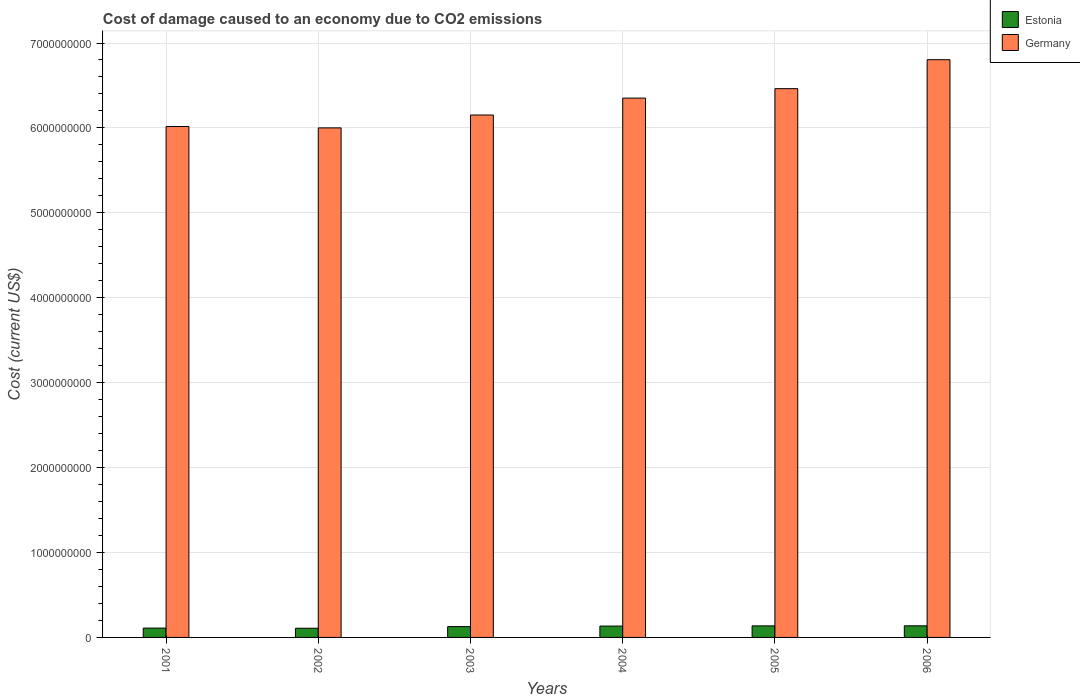How many different coloured bars are there?
Your answer should be very brief. 2. How many groups of bars are there?
Make the answer very short. 6. Are the number of bars per tick equal to the number of legend labels?
Your answer should be compact. Yes. What is the label of the 2nd group of bars from the left?
Your response must be concise. 2002. In how many cases, is the number of bars for a given year not equal to the number of legend labels?
Your answer should be very brief. 0. What is the cost of damage caused due to CO2 emissisons in Germany in 2005?
Provide a succinct answer. 6.46e+09. Across all years, what is the maximum cost of damage caused due to CO2 emissisons in Estonia?
Ensure brevity in your answer.  1.37e+08. Across all years, what is the minimum cost of damage caused due to CO2 emissisons in Estonia?
Provide a short and direct response. 1.08e+08. In which year was the cost of damage caused due to CO2 emissisons in Estonia minimum?
Your answer should be compact. 2002. What is the total cost of damage caused due to CO2 emissisons in Estonia in the graph?
Provide a short and direct response. 7.52e+08. What is the difference between the cost of damage caused due to CO2 emissisons in Estonia in 2001 and that in 2003?
Ensure brevity in your answer.  -1.75e+07. What is the difference between the cost of damage caused due to CO2 emissisons in Estonia in 2005 and the cost of damage caused due to CO2 emissisons in Germany in 2001?
Offer a very short reply. -5.88e+09. What is the average cost of damage caused due to CO2 emissisons in Germany per year?
Ensure brevity in your answer.  6.30e+09. In the year 2006, what is the difference between the cost of damage caused due to CO2 emissisons in Estonia and cost of damage caused due to CO2 emissisons in Germany?
Keep it short and to the point. -6.67e+09. In how many years, is the cost of damage caused due to CO2 emissisons in Germany greater than 5400000000 US$?
Your answer should be very brief. 6. What is the ratio of the cost of damage caused due to CO2 emissisons in Estonia in 2001 to that in 2006?
Give a very brief answer. 0.8. What is the difference between the highest and the second highest cost of damage caused due to CO2 emissisons in Germany?
Provide a succinct answer. 3.41e+08. What is the difference between the highest and the lowest cost of damage caused due to CO2 emissisons in Germany?
Your response must be concise. 8.03e+08. What does the 2nd bar from the left in 2006 represents?
Provide a succinct answer. Germany. What does the 1st bar from the right in 2005 represents?
Offer a very short reply. Germany. Are all the bars in the graph horizontal?
Your response must be concise. No. Are the values on the major ticks of Y-axis written in scientific E-notation?
Keep it short and to the point. No. Does the graph contain any zero values?
Keep it short and to the point. No. Does the graph contain grids?
Offer a very short reply. Yes. Where does the legend appear in the graph?
Your response must be concise. Top right. What is the title of the graph?
Ensure brevity in your answer.  Cost of damage caused to an economy due to CO2 emissions. Does "Guyana" appear as one of the legend labels in the graph?
Your answer should be very brief. No. What is the label or title of the X-axis?
Give a very brief answer. Years. What is the label or title of the Y-axis?
Provide a short and direct response. Cost (current US$). What is the Cost (current US$) in Estonia in 2001?
Provide a succinct answer. 1.10e+08. What is the Cost (current US$) of Germany in 2001?
Keep it short and to the point. 6.02e+09. What is the Cost (current US$) of Estonia in 2002?
Keep it short and to the point. 1.08e+08. What is the Cost (current US$) in Germany in 2002?
Give a very brief answer. 6.00e+09. What is the Cost (current US$) in Estonia in 2003?
Offer a terse response. 1.27e+08. What is the Cost (current US$) in Germany in 2003?
Make the answer very short. 6.15e+09. What is the Cost (current US$) in Estonia in 2004?
Make the answer very short. 1.34e+08. What is the Cost (current US$) of Germany in 2004?
Provide a short and direct response. 6.35e+09. What is the Cost (current US$) of Estonia in 2005?
Provide a succinct answer. 1.36e+08. What is the Cost (current US$) of Germany in 2005?
Keep it short and to the point. 6.46e+09. What is the Cost (current US$) of Estonia in 2006?
Keep it short and to the point. 1.37e+08. What is the Cost (current US$) in Germany in 2006?
Your answer should be very brief. 6.80e+09. Across all years, what is the maximum Cost (current US$) in Estonia?
Provide a short and direct response. 1.37e+08. Across all years, what is the maximum Cost (current US$) of Germany?
Keep it short and to the point. 6.80e+09. Across all years, what is the minimum Cost (current US$) in Estonia?
Keep it short and to the point. 1.08e+08. Across all years, what is the minimum Cost (current US$) of Germany?
Ensure brevity in your answer.  6.00e+09. What is the total Cost (current US$) of Estonia in the graph?
Make the answer very short. 7.52e+08. What is the total Cost (current US$) in Germany in the graph?
Your response must be concise. 3.78e+1. What is the difference between the Cost (current US$) in Estonia in 2001 and that in 2002?
Make the answer very short. 1.78e+06. What is the difference between the Cost (current US$) in Germany in 2001 and that in 2002?
Keep it short and to the point. 1.60e+07. What is the difference between the Cost (current US$) in Estonia in 2001 and that in 2003?
Keep it short and to the point. -1.75e+07. What is the difference between the Cost (current US$) in Germany in 2001 and that in 2003?
Offer a terse response. -1.35e+08. What is the difference between the Cost (current US$) of Estonia in 2001 and that in 2004?
Your answer should be very brief. -2.38e+07. What is the difference between the Cost (current US$) of Germany in 2001 and that in 2004?
Your answer should be compact. -3.35e+08. What is the difference between the Cost (current US$) in Estonia in 2001 and that in 2005?
Your answer should be compact. -2.61e+07. What is the difference between the Cost (current US$) of Germany in 2001 and that in 2005?
Keep it short and to the point. -4.46e+08. What is the difference between the Cost (current US$) in Estonia in 2001 and that in 2006?
Give a very brief answer. -2.68e+07. What is the difference between the Cost (current US$) in Germany in 2001 and that in 2006?
Offer a terse response. -7.87e+08. What is the difference between the Cost (current US$) of Estonia in 2002 and that in 2003?
Your answer should be very brief. -1.93e+07. What is the difference between the Cost (current US$) in Germany in 2002 and that in 2003?
Your response must be concise. -1.51e+08. What is the difference between the Cost (current US$) in Estonia in 2002 and that in 2004?
Your response must be concise. -2.56e+07. What is the difference between the Cost (current US$) in Germany in 2002 and that in 2004?
Your answer should be compact. -3.51e+08. What is the difference between the Cost (current US$) of Estonia in 2002 and that in 2005?
Ensure brevity in your answer.  -2.79e+07. What is the difference between the Cost (current US$) in Germany in 2002 and that in 2005?
Your answer should be very brief. -4.62e+08. What is the difference between the Cost (current US$) in Estonia in 2002 and that in 2006?
Your answer should be very brief. -2.85e+07. What is the difference between the Cost (current US$) in Germany in 2002 and that in 2006?
Give a very brief answer. -8.03e+08. What is the difference between the Cost (current US$) in Estonia in 2003 and that in 2004?
Provide a succinct answer. -6.32e+06. What is the difference between the Cost (current US$) of Germany in 2003 and that in 2004?
Your answer should be very brief. -1.99e+08. What is the difference between the Cost (current US$) in Estonia in 2003 and that in 2005?
Your answer should be very brief. -8.61e+06. What is the difference between the Cost (current US$) of Germany in 2003 and that in 2005?
Ensure brevity in your answer.  -3.11e+08. What is the difference between the Cost (current US$) of Estonia in 2003 and that in 2006?
Ensure brevity in your answer.  -9.28e+06. What is the difference between the Cost (current US$) of Germany in 2003 and that in 2006?
Offer a terse response. -6.51e+08. What is the difference between the Cost (current US$) of Estonia in 2004 and that in 2005?
Offer a terse response. -2.29e+06. What is the difference between the Cost (current US$) in Germany in 2004 and that in 2005?
Provide a succinct answer. -1.11e+08. What is the difference between the Cost (current US$) of Estonia in 2004 and that in 2006?
Your response must be concise. -2.96e+06. What is the difference between the Cost (current US$) of Germany in 2004 and that in 2006?
Offer a terse response. -4.52e+08. What is the difference between the Cost (current US$) of Estonia in 2005 and that in 2006?
Make the answer very short. -6.68e+05. What is the difference between the Cost (current US$) of Germany in 2005 and that in 2006?
Give a very brief answer. -3.41e+08. What is the difference between the Cost (current US$) of Estonia in 2001 and the Cost (current US$) of Germany in 2002?
Ensure brevity in your answer.  -5.89e+09. What is the difference between the Cost (current US$) in Estonia in 2001 and the Cost (current US$) in Germany in 2003?
Your response must be concise. -6.04e+09. What is the difference between the Cost (current US$) of Estonia in 2001 and the Cost (current US$) of Germany in 2004?
Give a very brief answer. -6.24e+09. What is the difference between the Cost (current US$) in Estonia in 2001 and the Cost (current US$) in Germany in 2005?
Your answer should be very brief. -6.35e+09. What is the difference between the Cost (current US$) in Estonia in 2001 and the Cost (current US$) in Germany in 2006?
Provide a short and direct response. -6.69e+09. What is the difference between the Cost (current US$) in Estonia in 2002 and the Cost (current US$) in Germany in 2003?
Offer a terse response. -6.04e+09. What is the difference between the Cost (current US$) of Estonia in 2002 and the Cost (current US$) of Germany in 2004?
Make the answer very short. -6.24e+09. What is the difference between the Cost (current US$) in Estonia in 2002 and the Cost (current US$) in Germany in 2005?
Keep it short and to the point. -6.35e+09. What is the difference between the Cost (current US$) of Estonia in 2002 and the Cost (current US$) of Germany in 2006?
Your answer should be compact. -6.70e+09. What is the difference between the Cost (current US$) in Estonia in 2003 and the Cost (current US$) in Germany in 2004?
Provide a short and direct response. -6.22e+09. What is the difference between the Cost (current US$) in Estonia in 2003 and the Cost (current US$) in Germany in 2005?
Give a very brief answer. -6.33e+09. What is the difference between the Cost (current US$) of Estonia in 2003 and the Cost (current US$) of Germany in 2006?
Your response must be concise. -6.68e+09. What is the difference between the Cost (current US$) of Estonia in 2004 and the Cost (current US$) of Germany in 2005?
Keep it short and to the point. -6.33e+09. What is the difference between the Cost (current US$) in Estonia in 2004 and the Cost (current US$) in Germany in 2006?
Give a very brief answer. -6.67e+09. What is the difference between the Cost (current US$) of Estonia in 2005 and the Cost (current US$) of Germany in 2006?
Give a very brief answer. -6.67e+09. What is the average Cost (current US$) of Estonia per year?
Offer a very short reply. 1.25e+08. What is the average Cost (current US$) of Germany per year?
Ensure brevity in your answer.  6.30e+09. In the year 2001, what is the difference between the Cost (current US$) in Estonia and Cost (current US$) in Germany?
Keep it short and to the point. -5.91e+09. In the year 2002, what is the difference between the Cost (current US$) in Estonia and Cost (current US$) in Germany?
Your response must be concise. -5.89e+09. In the year 2003, what is the difference between the Cost (current US$) in Estonia and Cost (current US$) in Germany?
Your answer should be very brief. -6.02e+09. In the year 2004, what is the difference between the Cost (current US$) in Estonia and Cost (current US$) in Germany?
Provide a succinct answer. -6.22e+09. In the year 2005, what is the difference between the Cost (current US$) of Estonia and Cost (current US$) of Germany?
Keep it short and to the point. -6.33e+09. In the year 2006, what is the difference between the Cost (current US$) of Estonia and Cost (current US$) of Germany?
Make the answer very short. -6.67e+09. What is the ratio of the Cost (current US$) in Estonia in 2001 to that in 2002?
Provide a short and direct response. 1.02. What is the ratio of the Cost (current US$) of Estonia in 2001 to that in 2003?
Offer a very short reply. 0.86. What is the ratio of the Cost (current US$) of Estonia in 2001 to that in 2004?
Make the answer very short. 0.82. What is the ratio of the Cost (current US$) of Germany in 2001 to that in 2004?
Your answer should be very brief. 0.95. What is the ratio of the Cost (current US$) of Estonia in 2001 to that in 2005?
Your answer should be compact. 0.81. What is the ratio of the Cost (current US$) of Estonia in 2001 to that in 2006?
Give a very brief answer. 0.8. What is the ratio of the Cost (current US$) of Germany in 2001 to that in 2006?
Provide a short and direct response. 0.88. What is the ratio of the Cost (current US$) in Estonia in 2002 to that in 2003?
Offer a terse response. 0.85. What is the ratio of the Cost (current US$) of Germany in 2002 to that in 2003?
Your response must be concise. 0.98. What is the ratio of the Cost (current US$) in Estonia in 2002 to that in 2004?
Offer a terse response. 0.81. What is the ratio of the Cost (current US$) in Germany in 2002 to that in 2004?
Provide a succinct answer. 0.94. What is the ratio of the Cost (current US$) in Estonia in 2002 to that in 2005?
Make the answer very short. 0.8. What is the ratio of the Cost (current US$) in Germany in 2002 to that in 2005?
Offer a very short reply. 0.93. What is the ratio of the Cost (current US$) of Estonia in 2002 to that in 2006?
Your answer should be compact. 0.79. What is the ratio of the Cost (current US$) of Germany in 2002 to that in 2006?
Ensure brevity in your answer.  0.88. What is the ratio of the Cost (current US$) of Estonia in 2003 to that in 2004?
Give a very brief answer. 0.95. What is the ratio of the Cost (current US$) of Germany in 2003 to that in 2004?
Offer a very short reply. 0.97. What is the ratio of the Cost (current US$) in Estonia in 2003 to that in 2005?
Offer a terse response. 0.94. What is the ratio of the Cost (current US$) of Germany in 2003 to that in 2005?
Your answer should be compact. 0.95. What is the ratio of the Cost (current US$) of Estonia in 2003 to that in 2006?
Give a very brief answer. 0.93. What is the ratio of the Cost (current US$) in Germany in 2003 to that in 2006?
Your response must be concise. 0.9. What is the ratio of the Cost (current US$) in Estonia in 2004 to that in 2005?
Your answer should be very brief. 0.98. What is the ratio of the Cost (current US$) in Germany in 2004 to that in 2005?
Make the answer very short. 0.98. What is the ratio of the Cost (current US$) of Estonia in 2004 to that in 2006?
Keep it short and to the point. 0.98. What is the ratio of the Cost (current US$) in Germany in 2004 to that in 2006?
Give a very brief answer. 0.93. What is the ratio of the Cost (current US$) in Estonia in 2005 to that in 2006?
Give a very brief answer. 1. What is the ratio of the Cost (current US$) in Germany in 2005 to that in 2006?
Offer a very short reply. 0.95. What is the difference between the highest and the second highest Cost (current US$) in Estonia?
Ensure brevity in your answer.  6.68e+05. What is the difference between the highest and the second highest Cost (current US$) of Germany?
Provide a short and direct response. 3.41e+08. What is the difference between the highest and the lowest Cost (current US$) in Estonia?
Offer a very short reply. 2.85e+07. What is the difference between the highest and the lowest Cost (current US$) of Germany?
Make the answer very short. 8.03e+08. 